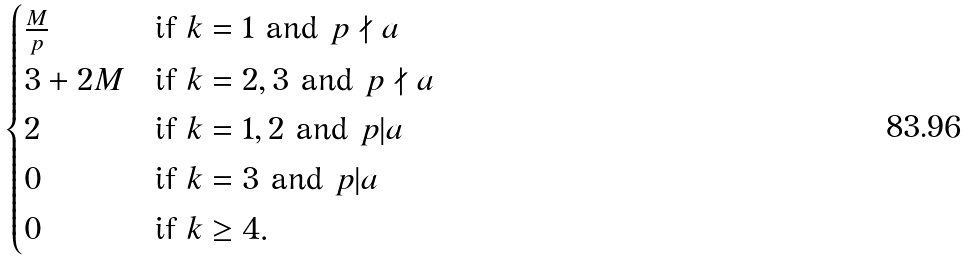<formula> <loc_0><loc_0><loc_500><loc_500>\begin{cases} \frac { M } { p } & \text {if} \ k = 1 \ \text {and} \ p \nmid a \\ 3 + 2 M & \text {if} \ k = 2 , 3 \ \text {and} \ p \nmid a \\ 2 & \text {if} \ k = 1 , 2 \ \text {and} \ p | a \\ 0 & \text {if} \ k = 3 \ \text {and} \ p | a \\ 0 & \text {if} \ k \geq 4 . \end{cases}</formula> 